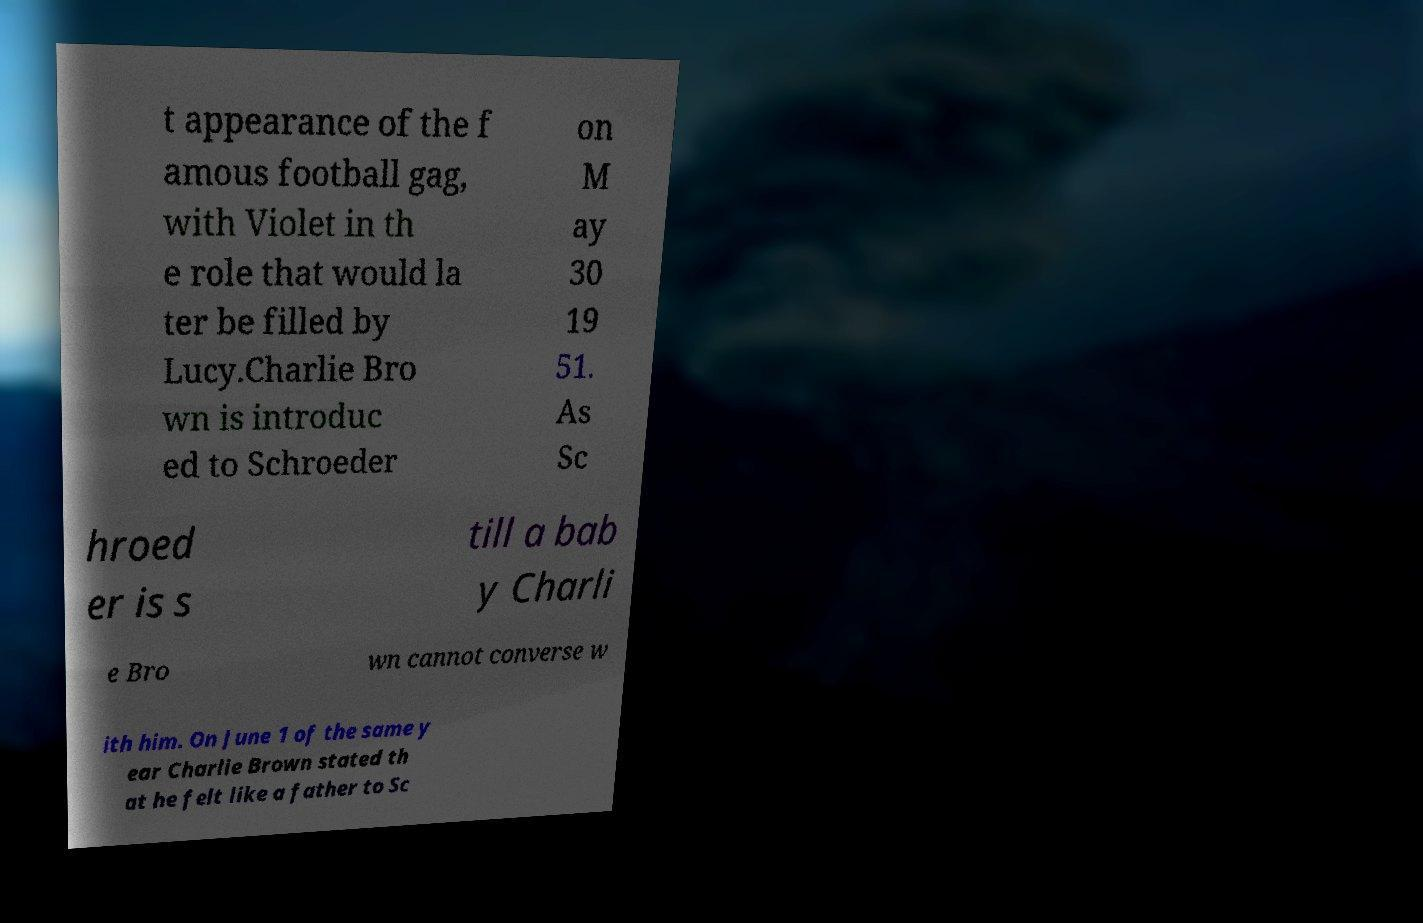For documentation purposes, I need the text within this image transcribed. Could you provide that? t appearance of the f amous football gag, with Violet in th e role that would la ter be filled by Lucy.Charlie Bro wn is introduc ed to Schroeder on M ay 30 19 51. As Sc hroed er is s till a bab y Charli e Bro wn cannot converse w ith him. On June 1 of the same y ear Charlie Brown stated th at he felt like a father to Sc 